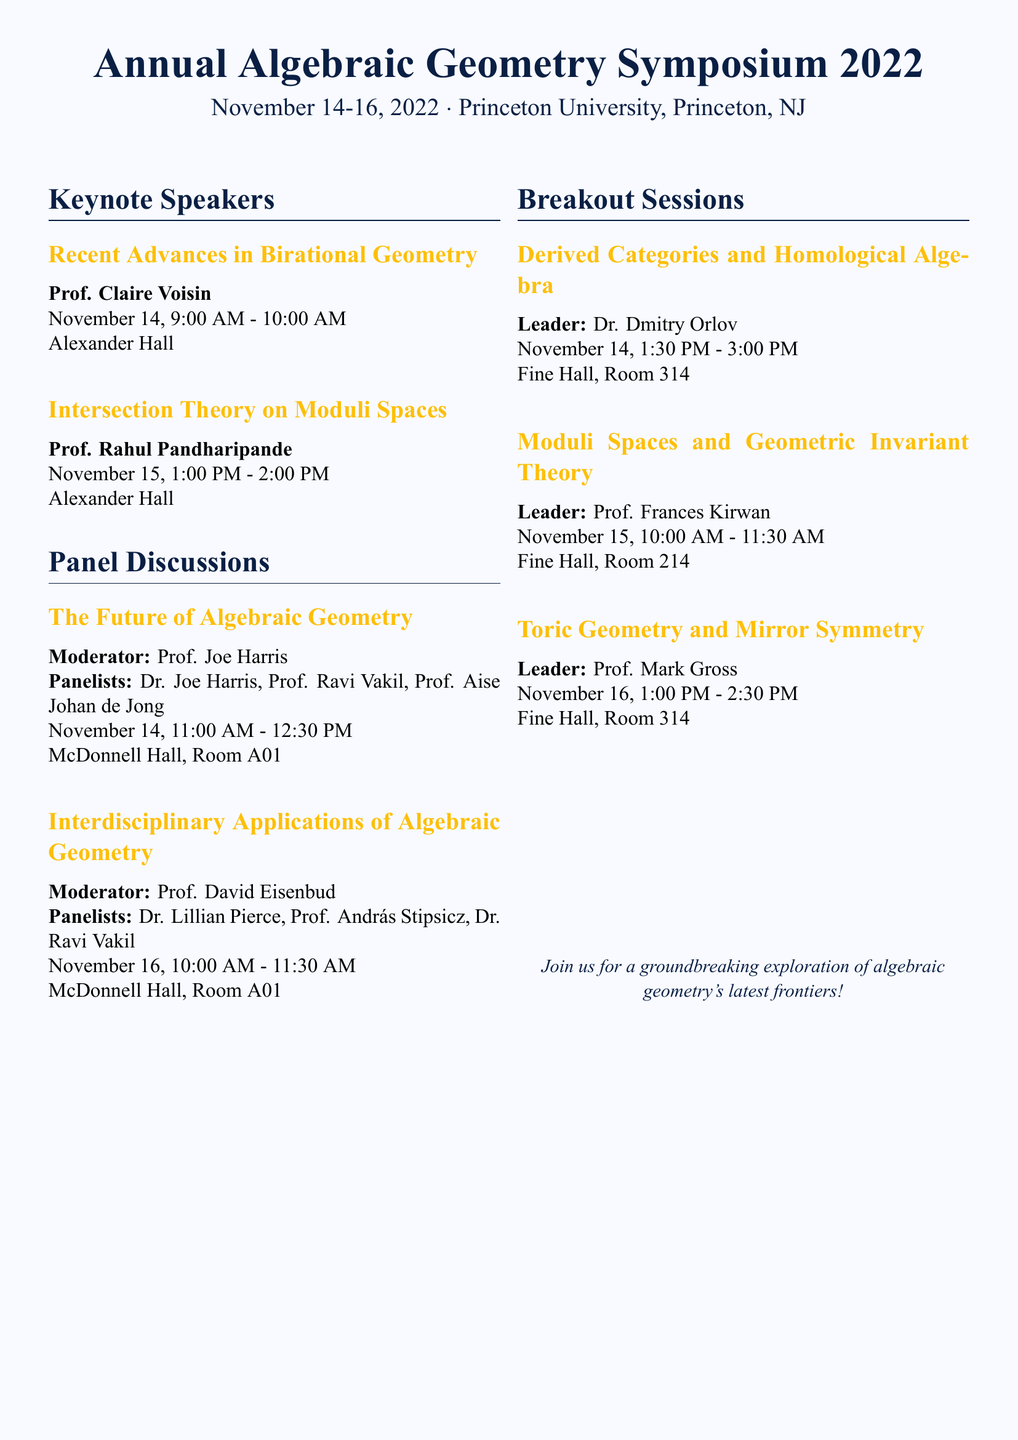What are the dates of the symposium? The symposium is scheduled from November 14 to November 16, 2022.
Answer: November 14-16, 2022 Who is the first keynote speaker? The first keynote speaker listed is Prof. Claire Voisin, who is presenting on November 14.
Answer: Prof. Claire Voisin What is the title of Prof. Rahul Pandharipande's keynote? Prof. Rahul Pandharipande's keynote title is provided in the program.
Answer: Intersection Theory on Moduli Spaces How many panel discussions are scheduled? The document lists two panel discussions taking place during the symposium.
Answer: 2 What is the location for the future of algebraic geometry panel discussion? The location for the panel discussion "The Future of Algebraic Geometry" is mentioned in the document.
Answer: McDonnell Hall, Room A01 Who leads the breakout session on Derived Categories and Homological Algebra? The leader of the specific breakout session is documented clearly.
Answer: Dr. Dmitry Orlov What time does the discussion on Interdisciplinary Applications of Algebraic Geometry begin? The start time for this discussion is specified in the schedule.
Answer: 10:00 AM Which room contains the session on Toric Geometry and Mirror Symmetry? The document mentions the location for this breakout session.
Answer: Fine Hall, Room 314 